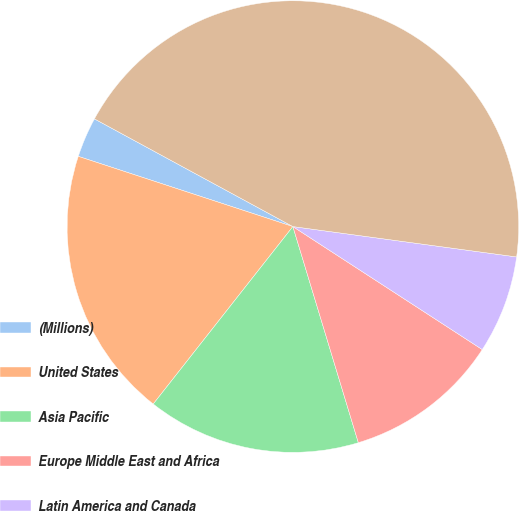Convert chart to OTSL. <chart><loc_0><loc_0><loc_500><loc_500><pie_chart><fcel>(Millions)<fcel>United States<fcel>Asia Pacific<fcel>Europe Middle East and Africa<fcel>Latin America and Canada<fcel>Total Company<nl><fcel>2.88%<fcel>19.42%<fcel>15.29%<fcel>11.15%<fcel>7.02%<fcel>44.23%<nl></chart> 